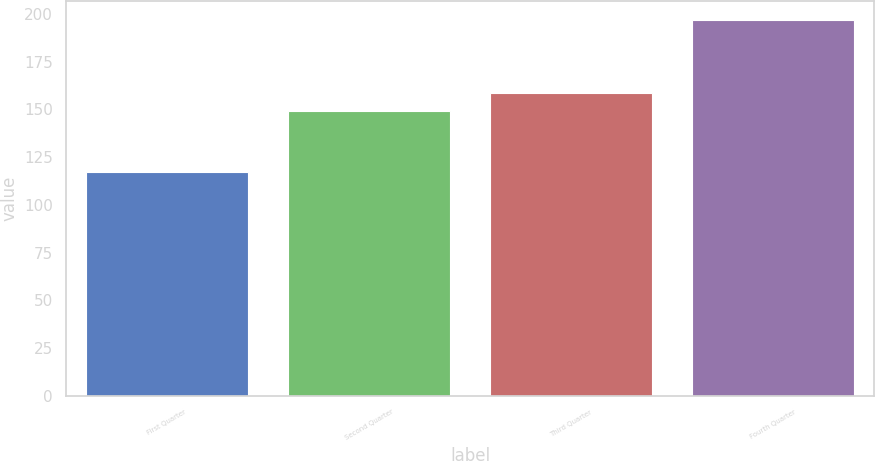<chart> <loc_0><loc_0><loc_500><loc_500><bar_chart><fcel>First Quarter<fcel>Second Quarter<fcel>Third Quarter<fcel>Fourth Quarter<nl><fcel>117.06<fcel>149.34<fcel>158.57<fcel>196.95<nl></chart> 